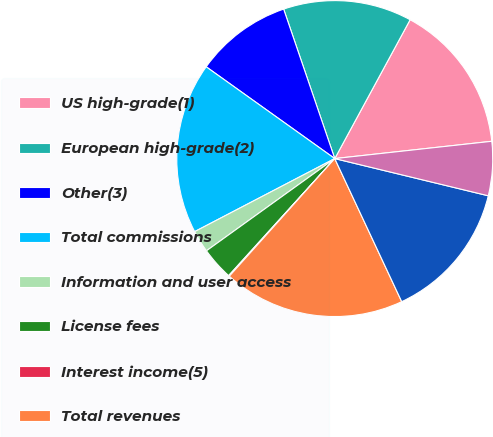<chart> <loc_0><loc_0><loc_500><loc_500><pie_chart><fcel>US high-grade(1)<fcel>European high-grade(2)<fcel>Other(3)<fcel>Total commissions<fcel>Information and user access<fcel>License fees<fcel>Interest income(5)<fcel>Total revenues<fcel>Employee compensation and<fcel>Depreciation and amortization<nl><fcel>15.34%<fcel>13.16%<fcel>9.89%<fcel>17.52%<fcel>2.27%<fcel>3.36%<fcel>0.09%<fcel>18.6%<fcel>14.25%<fcel>5.53%<nl></chart> 